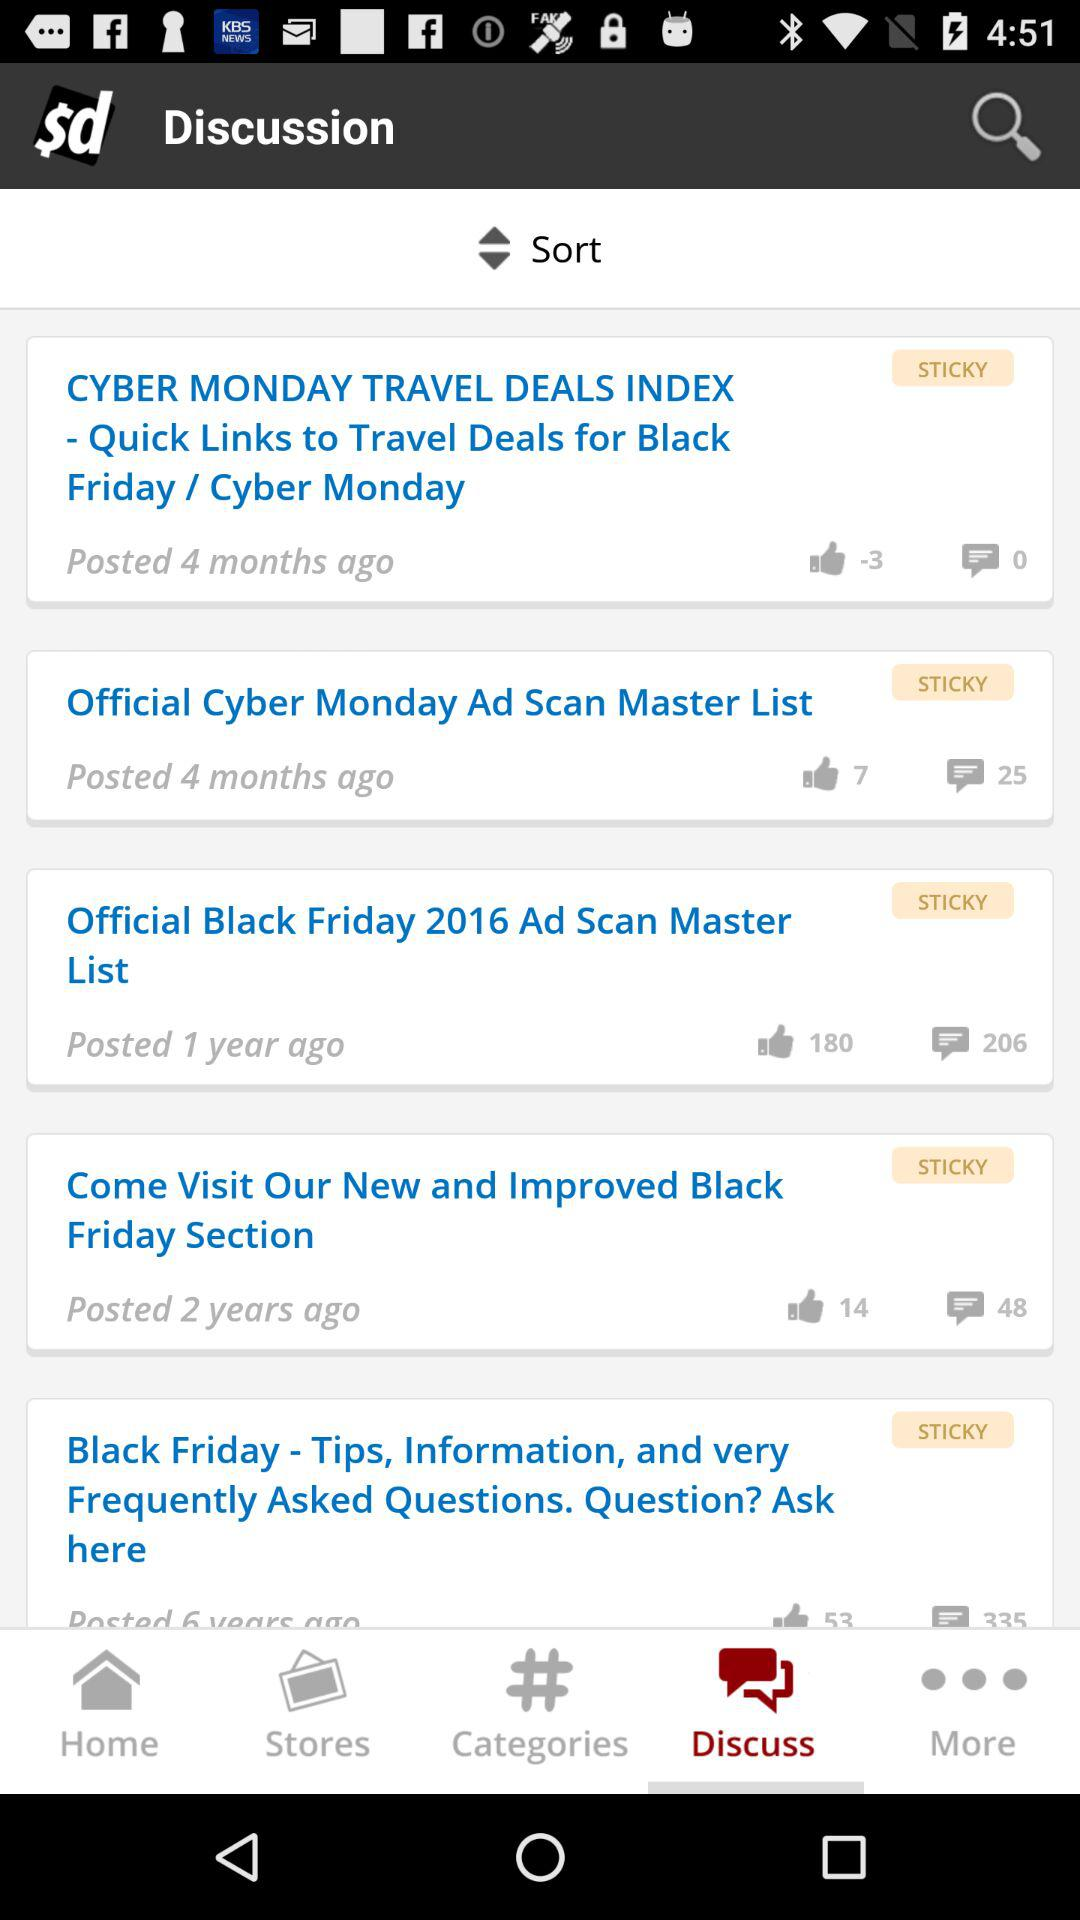How many comments on the post that was posted 2 years ago? There are 48 comments on the post that was posted 2 years ago. 